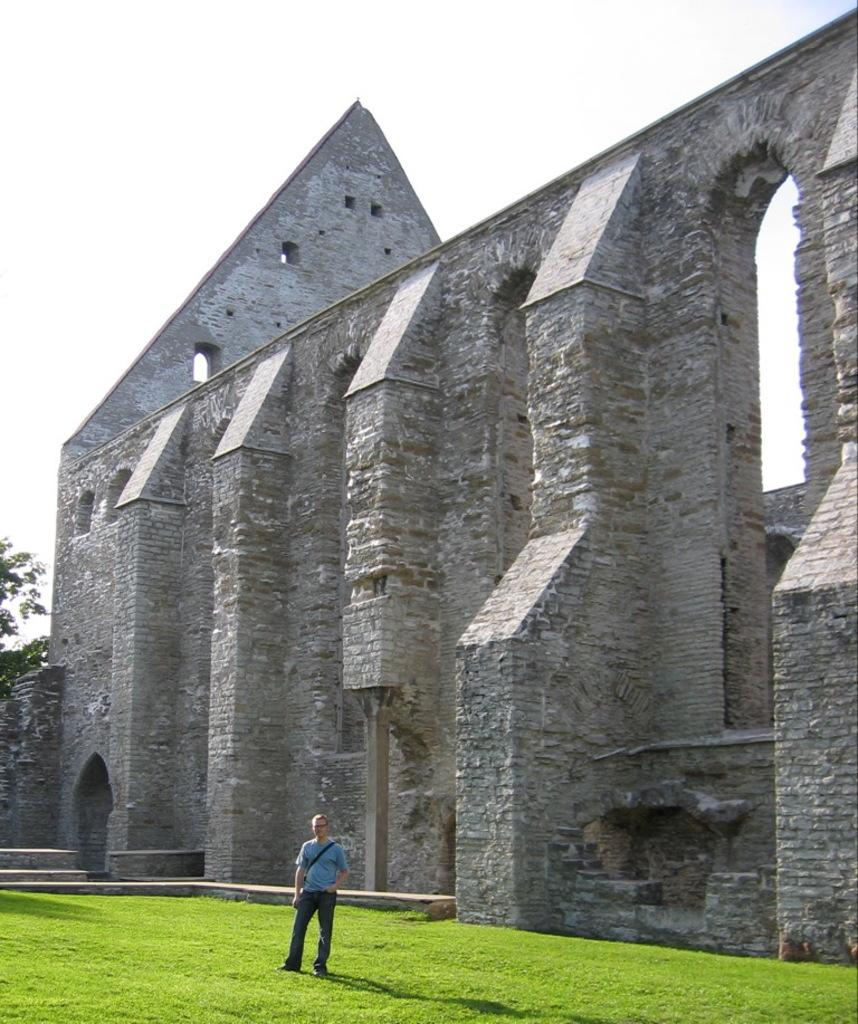What type of vegetation covers the land in the image? The land in the image is covered with grass. Can you describe the person in the image? There is a person standing on the grass in the image. What structure can be seen in the background of the image? There is a fort visible in the background of the image. What else can be seen in the background of the image? There is a tree and the sky visible in the background of the image. What type of juice is being served at the pie-eating contest in the image? There is no juice or pie-eating contest present in the image. 